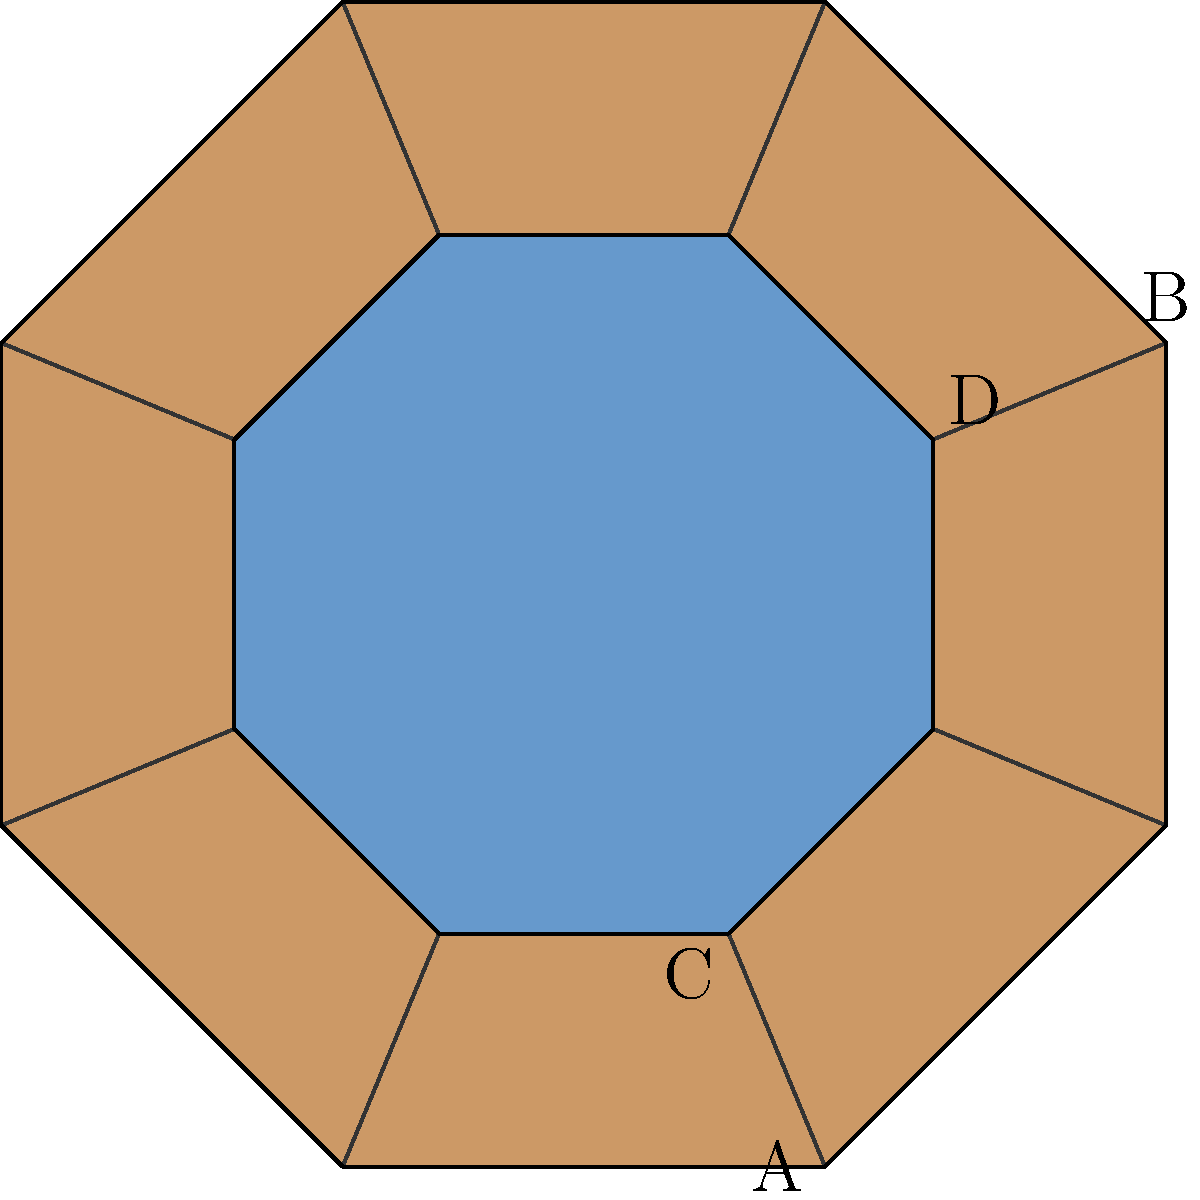In this Anishinaabe beadwork pattern, an octagonal shape is divided into congruent triangles. If triangle ABC is congruent to triangle ACD, what is the ratio of the side length of the inner octagon to the outer octagon? To solve this problem, let's follow these steps:

1) In an octagon, the central angle is $360^\circ \div 8 = 45^\circ$.

2) Triangle ABC and triangle ACD share the same angle at A, which is $45^\circ$.

3) For these triangles to be congruent, they must have the same shape and size. This means that angle BAC must equal angle CAD.

4) Since the sum of angles in a triangle is $180^\circ$, and we know one angle is $45^\circ$, the other two angles in each triangle must sum to $135^\circ$.

5) For the triangles to be congruent, these angles must be split equally. So, angle BAC = angle CAD = $67.5^\circ$.

6) In a right triangle with a $67.5^\circ$ angle, the ratio of the shorter side to the hypotenuse is:

   $\sin(67.5^\circ) = \frac{\text{shorter side}}{\text{hypotenuse}} \approx 0.9239$

7) This ratio represents the scale factor between the inner and outer octagons.

Therefore, the ratio of the side length of the inner octagon to the outer octagon is approximately 0.9239 to 1, or simply 0.9239.
Answer: 0.9239 : 1 